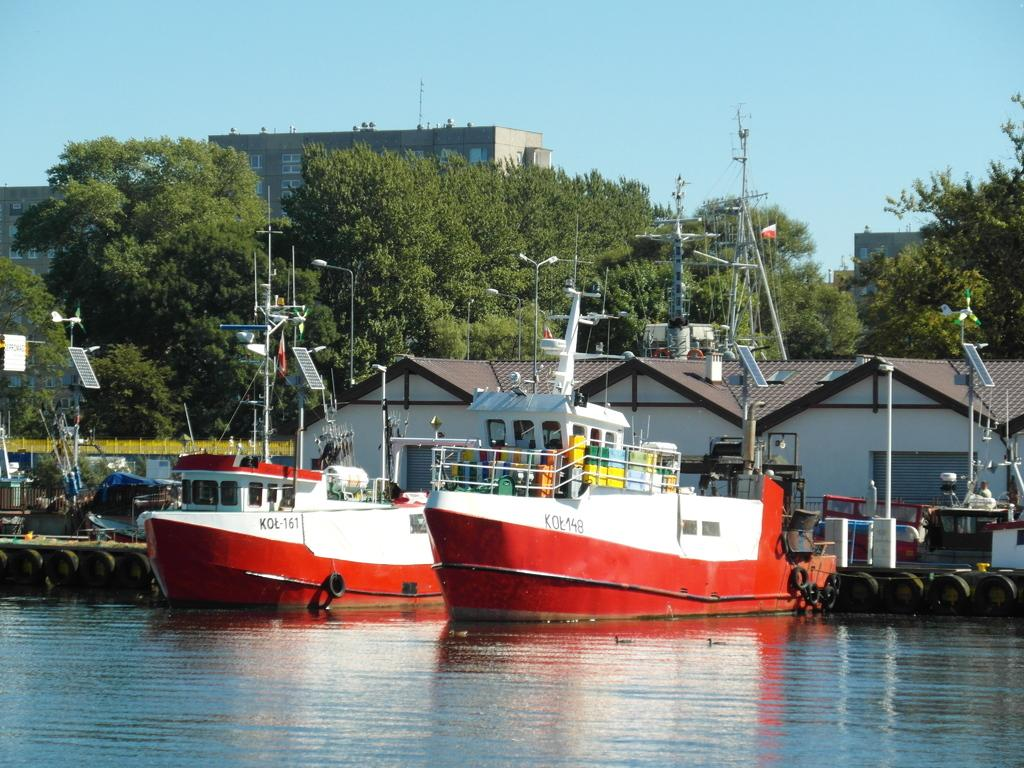What is the primary element in the image? There is water in the image. What is floating on the water? There are boats on the water. What structures can be seen in the image? There are sheds in the image. What can be seen in the background of the image? There are trees, buildings, and the sky visible in the background of the image. What type of creature is exhibiting unusual behavior in the middle of the image? There is no creature present in the image, and therefore no behavior can be observed. 